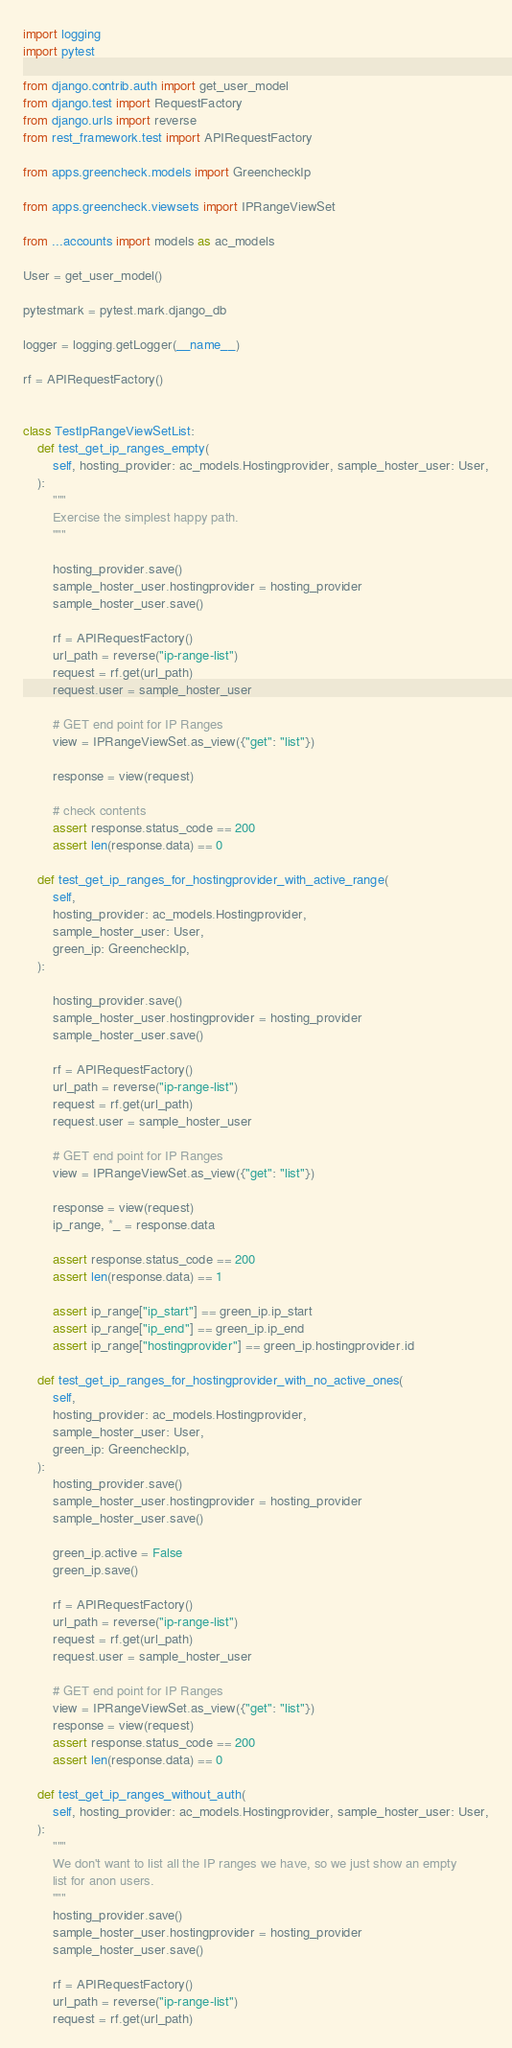Convert code to text. <code><loc_0><loc_0><loc_500><loc_500><_Python_>import logging
import pytest

from django.contrib.auth import get_user_model
from django.test import RequestFactory
from django.urls import reverse
from rest_framework.test import APIRequestFactory

from apps.greencheck.models import GreencheckIp

from apps.greencheck.viewsets import IPRangeViewSet

from ...accounts import models as ac_models

User = get_user_model()

pytestmark = pytest.mark.django_db

logger = logging.getLogger(__name__)

rf = APIRequestFactory()


class TestIpRangeViewSetList:
    def test_get_ip_ranges_empty(
        self, hosting_provider: ac_models.Hostingprovider, sample_hoster_user: User,
    ):
        """
        Exercise the simplest happy path.
        """

        hosting_provider.save()
        sample_hoster_user.hostingprovider = hosting_provider
        sample_hoster_user.save()

        rf = APIRequestFactory()
        url_path = reverse("ip-range-list")
        request = rf.get(url_path)
        request.user = sample_hoster_user

        # GET end point for IP Ranges
        view = IPRangeViewSet.as_view({"get": "list"})

        response = view(request)

        # check contents
        assert response.status_code == 200
        assert len(response.data) == 0

    def test_get_ip_ranges_for_hostingprovider_with_active_range(
        self,
        hosting_provider: ac_models.Hostingprovider,
        sample_hoster_user: User,
        green_ip: GreencheckIp,
    ):

        hosting_provider.save()
        sample_hoster_user.hostingprovider = hosting_provider
        sample_hoster_user.save()

        rf = APIRequestFactory()
        url_path = reverse("ip-range-list")
        request = rf.get(url_path)
        request.user = sample_hoster_user

        # GET end point for IP Ranges
        view = IPRangeViewSet.as_view({"get": "list"})

        response = view(request)
        ip_range, *_ = response.data

        assert response.status_code == 200
        assert len(response.data) == 1

        assert ip_range["ip_start"] == green_ip.ip_start
        assert ip_range["ip_end"] == green_ip.ip_end
        assert ip_range["hostingprovider"] == green_ip.hostingprovider.id

    def test_get_ip_ranges_for_hostingprovider_with_no_active_ones(
        self,
        hosting_provider: ac_models.Hostingprovider,
        sample_hoster_user: User,
        green_ip: GreencheckIp,
    ):
        hosting_provider.save()
        sample_hoster_user.hostingprovider = hosting_provider
        sample_hoster_user.save()

        green_ip.active = False
        green_ip.save()

        rf = APIRequestFactory()
        url_path = reverse("ip-range-list")
        request = rf.get(url_path)
        request.user = sample_hoster_user

        # GET end point for IP Ranges
        view = IPRangeViewSet.as_view({"get": "list"})
        response = view(request)
        assert response.status_code == 200
        assert len(response.data) == 0

    def test_get_ip_ranges_without_auth(
        self, hosting_provider: ac_models.Hostingprovider, sample_hoster_user: User,
    ):
        """
        We don't want to list all the IP ranges we have, so we just show an empty
        list for anon users.
        """
        hosting_provider.save()
        sample_hoster_user.hostingprovider = hosting_provider
        sample_hoster_user.save()

        rf = APIRequestFactory()
        url_path = reverse("ip-range-list")
        request = rf.get(url_path)
</code> 